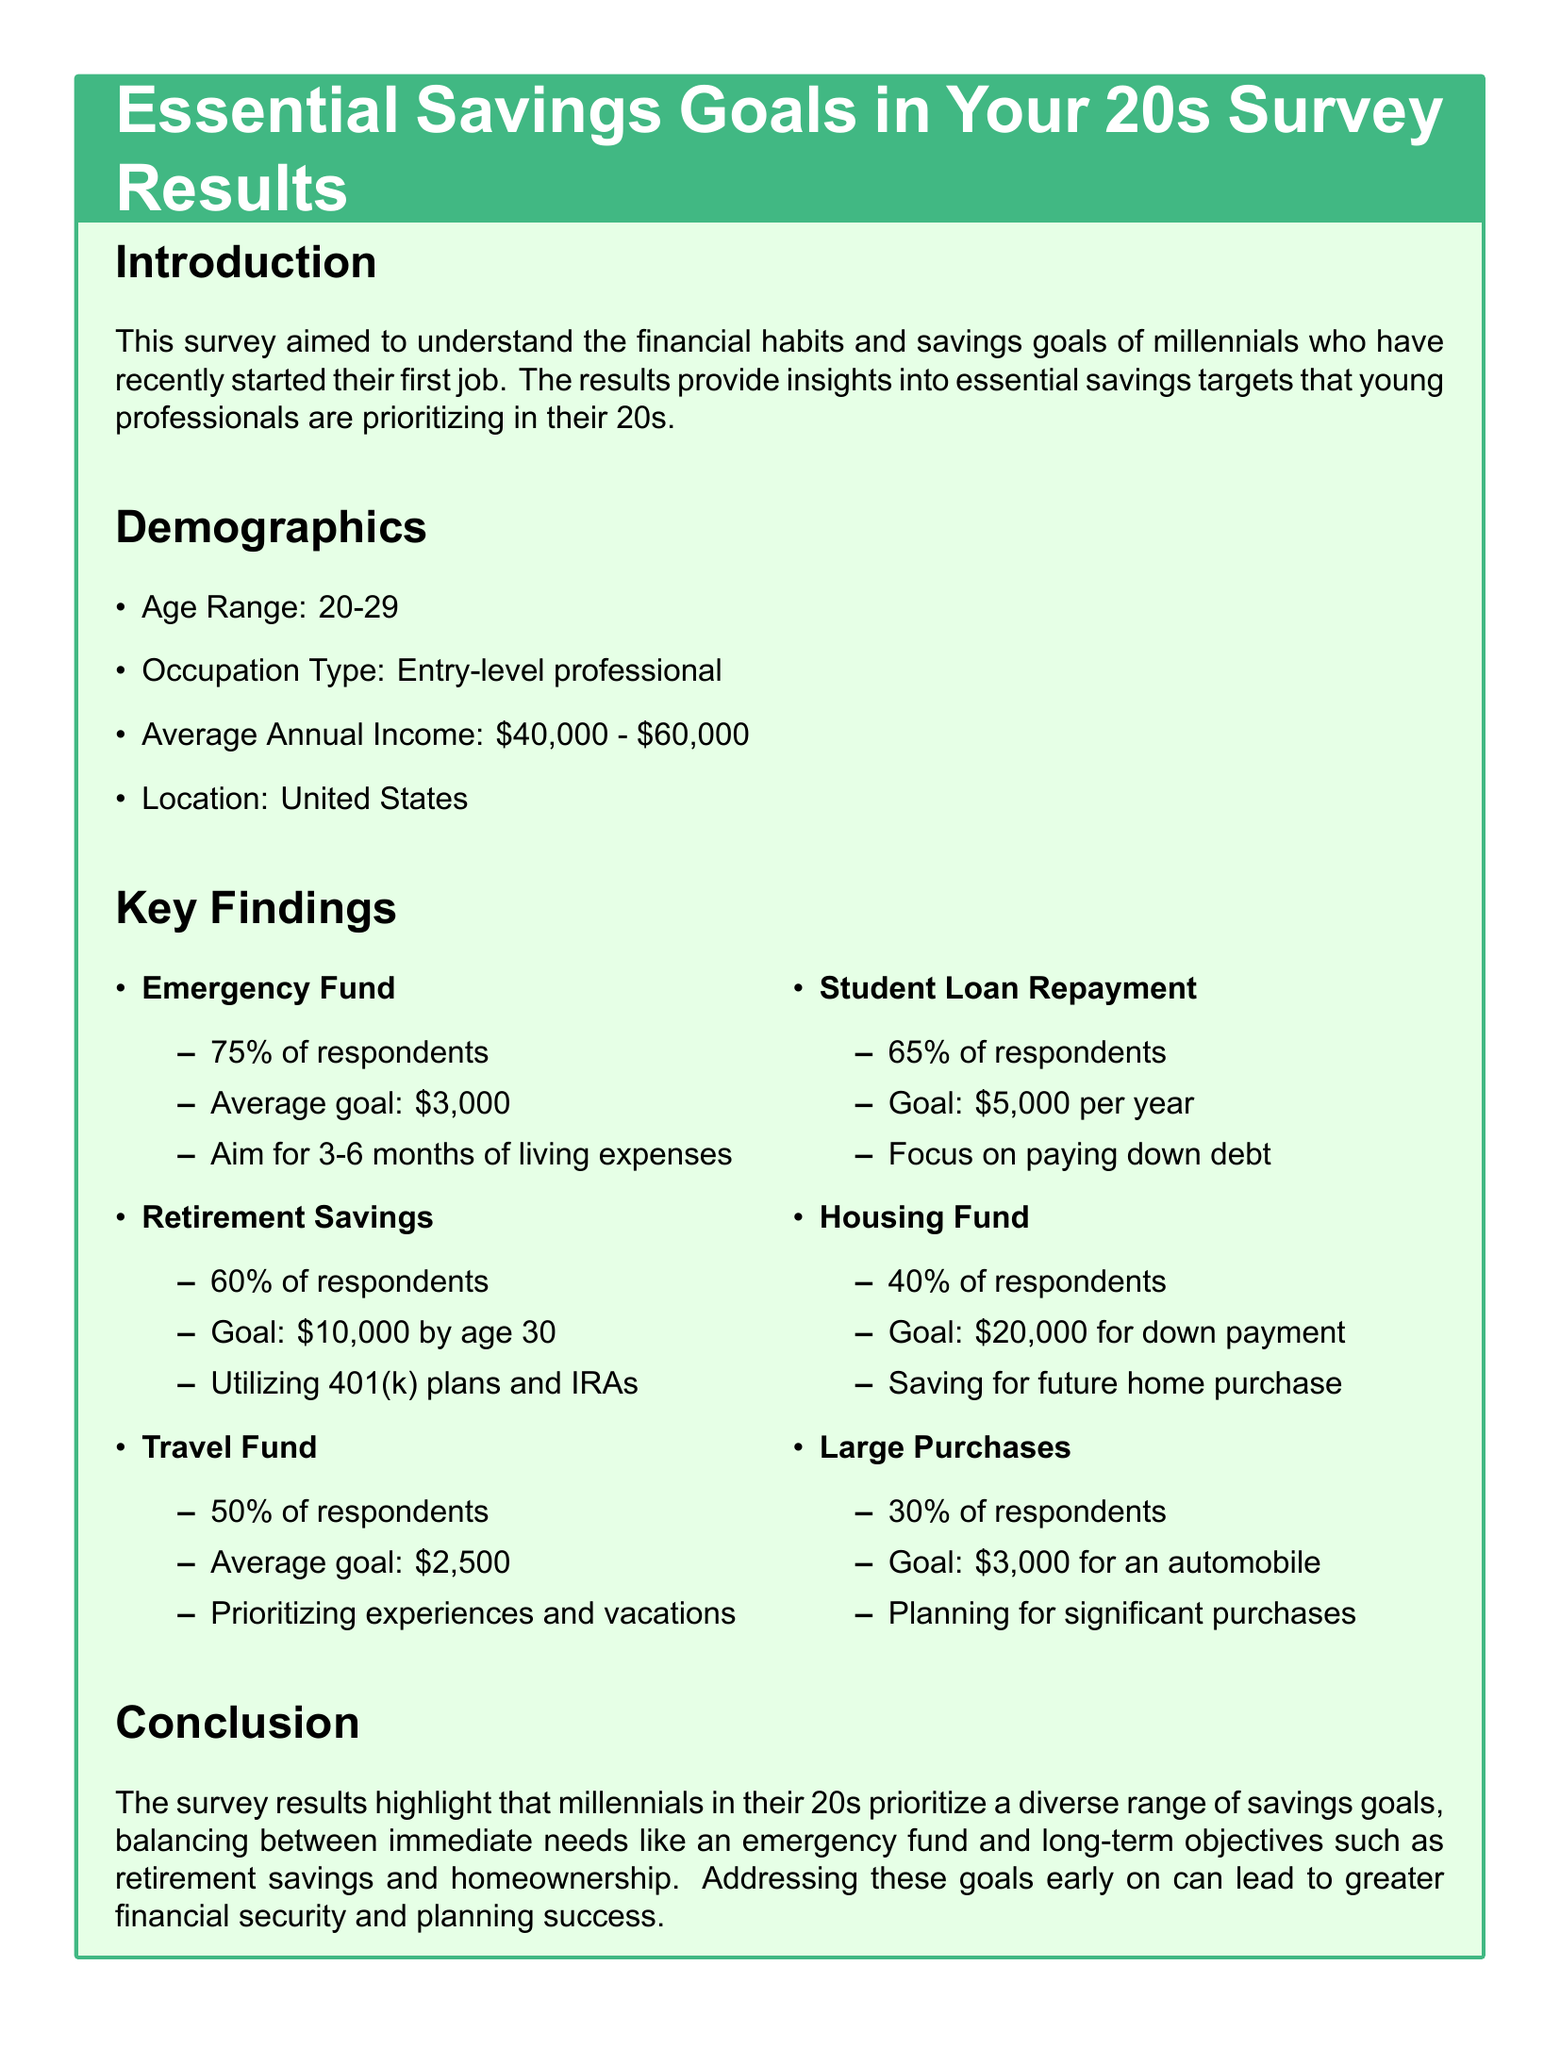what is the average annual income range of respondents? The average annual income range reported by respondents is \$40,000 - \$60,000.
Answer: \$40,000 - \$60,000 what percentage of respondents prioritize building an emergency fund? The document states that 75% of respondents prioritize building an emergency fund.
Answer: 75% what is the goal amount for retirement savings by age 30? The goal amount for retirement savings by age 30, according to the survey, is \$10,000.
Answer: \$10,000 how many months of living expenses do respondents aim to save for their emergency fund? Respondents aim to save for 3-6 months of living expenses in their emergency fund.
Answer: 3-6 months what is the average goal amount for a travel fund? The average goal for a travel fund reported in the survey is \$2,500.
Answer: \$2,500 what percentage of respondents have student loan repayment as a savings goal? According to the survey, 65% of respondents have student loan repayment as a savings goal.
Answer: 65% how many respondents are planning to save for a housing fund? The percentage of respondents planning to save for a housing fund is 40%.
Answer: 40% what is the savings goal for large purchases according to the survey? The savings goal for large purchases, such as an automobile, is set at \$3,000.
Answer: \$3,000 what type of document is this? This document is a survey results report focused on savings goals among millennials in their 20s.
Answer: survey results report 